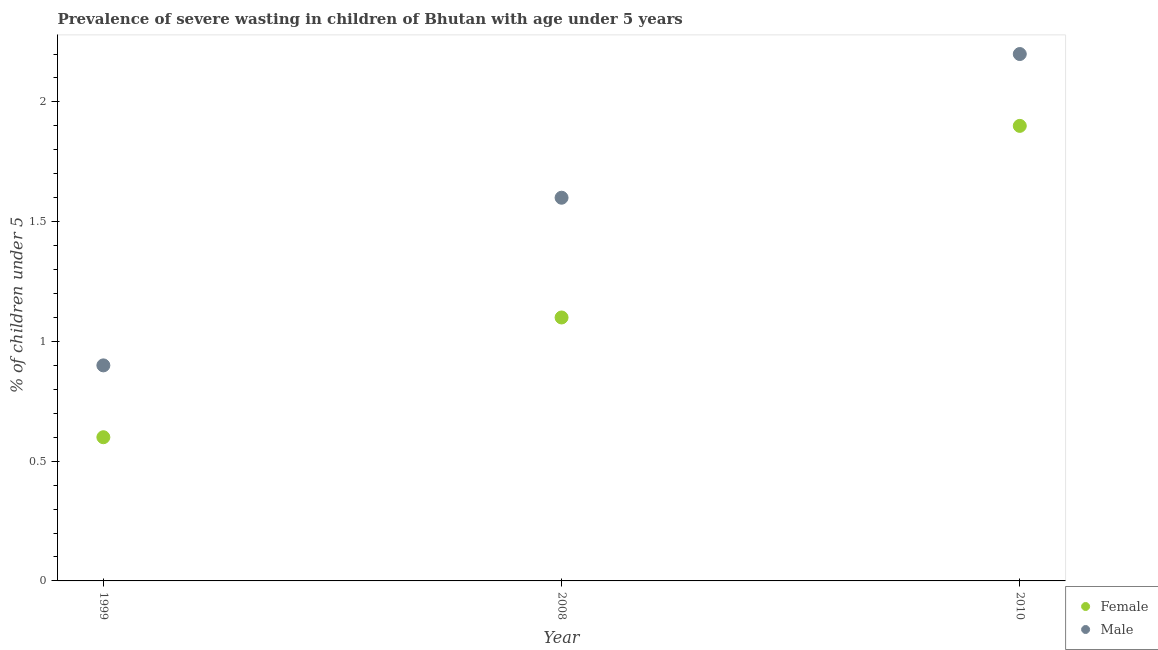Is the number of dotlines equal to the number of legend labels?
Your answer should be compact. Yes. What is the percentage of undernourished male children in 2010?
Provide a succinct answer. 2.2. Across all years, what is the maximum percentage of undernourished male children?
Give a very brief answer. 2.2. Across all years, what is the minimum percentage of undernourished female children?
Provide a succinct answer. 0.6. What is the total percentage of undernourished female children in the graph?
Keep it short and to the point. 3.6. What is the difference between the percentage of undernourished male children in 1999 and that in 2010?
Your response must be concise. -1.3. What is the difference between the percentage of undernourished female children in 1999 and the percentage of undernourished male children in 2008?
Make the answer very short. -1. What is the average percentage of undernourished female children per year?
Ensure brevity in your answer.  1.2. In the year 2010, what is the difference between the percentage of undernourished female children and percentage of undernourished male children?
Ensure brevity in your answer.  -0.3. What is the ratio of the percentage of undernourished male children in 1999 to that in 2008?
Make the answer very short. 0.56. Is the percentage of undernourished female children in 1999 less than that in 2010?
Ensure brevity in your answer.  Yes. What is the difference between the highest and the second highest percentage of undernourished female children?
Make the answer very short. 0.8. What is the difference between the highest and the lowest percentage of undernourished male children?
Provide a succinct answer. 1.3. In how many years, is the percentage of undernourished male children greater than the average percentage of undernourished male children taken over all years?
Make the answer very short. 2. Is the sum of the percentage of undernourished male children in 1999 and 2010 greater than the maximum percentage of undernourished female children across all years?
Give a very brief answer. Yes. Is the percentage of undernourished female children strictly greater than the percentage of undernourished male children over the years?
Make the answer very short. No. Is the percentage of undernourished female children strictly less than the percentage of undernourished male children over the years?
Your answer should be compact. Yes. How many dotlines are there?
Ensure brevity in your answer.  2. Are the values on the major ticks of Y-axis written in scientific E-notation?
Offer a very short reply. No. Does the graph contain any zero values?
Keep it short and to the point. No. Where does the legend appear in the graph?
Give a very brief answer. Bottom right. What is the title of the graph?
Your answer should be compact. Prevalence of severe wasting in children of Bhutan with age under 5 years. What is the label or title of the X-axis?
Offer a terse response. Year. What is the label or title of the Y-axis?
Offer a very short reply.  % of children under 5. What is the  % of children under 5 of Female in 1999?
Your response must be concise. 0.6. What is the  % of children under 5 of Male in 1999?
Keep it short and to the point. 0.9. What is the  % of children under 5 in Female in 2008?
Ensure brevity in your answer.  1.1. What is the  % of children under 5 of Male in 2008?
Provide a short and direct response. 1.6. What is the  % of children under 5 of Female in 2010?
Give a very brief answer. 1.9. What is the  % of children under 5 in Male in 2010?
Your answer should be compact. 2.2. Across all years, what is the maximum  % of children under 5 of Female?
Your answer should be very brief. 1.9. Across all years, what is the maximum  % of children under 5 in Male?
Provide a succinct answer. 2.2. Across all years, what is the minimum  % of children under 5 in Female?
Your answer should be compact. 0.6. Across all years, what is the minimum  % of children under 5 in Male?
Provide a short and direct response. 0.9. What is the total  % of children under 5 of Female in the graph?
Your answer should be compact. 3.6. What is the difference between the  % of children under 5 of Female in 1999 and that in 2008?
Keep it short and to the point. -0.5. What is the difference between the  % of children under 5 of Female in 1999 and the  % of children under 5 of Male in 2008?
Keep it short and to the point. -1. What is the average  % of children under 5 in Male per year?
Provide a succinct answer. 1.57. In the year 2010, what is the difference between the  % of children under 5 of Female and  % of children under 5 of Male?
Keep it short and to the point. -0.3. What is the ratio of the  % of children under 5 in Female in 1999 to that in 2008?
Your response must be concise. 0.55. What is the ratio of the  % of children under 5 of Male in 1999 to that in 2008?
Your answer should be very brief. 0.56. What is the ratio of the  % of children under 5 in Female in 1999 to that in 2010?
Your answer should be very brief. 0.32. What is the ratio of the  % of children under 5 in Male in 1999 to that in 2010?
Make the answer very short. 0.41. What is the ratio of the  % of children under 5 of Female in 2008 to that in 2010?
Your answer should be very brief. 0.58. What is the ratio of the  % of children under 5 in Male in 2008 to that in 2010?
Provide a short and direct response. 0.73. What is the difference between the highest and the second highest  % of children under 5 in Male?
Offer a terse response. 0.6. What is the difference between the highest and the lowest  % of children under 5 in Female?
Offer a terse response. 1.3. What is the difference between the highest and the lowest  % of children under 5 of Male?
Provide a succinct answer. 1.3. 